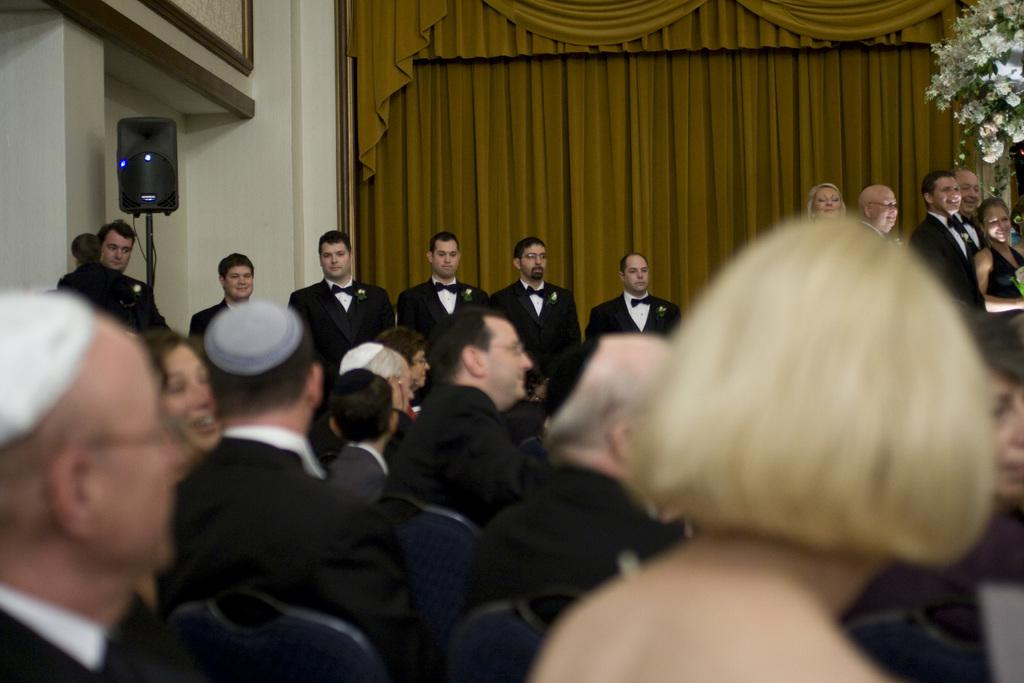What are the people in the image doing? The people in the image are sitting on chairs. Are there any other people visible in the image? Yes, there are people standing in the background of the image. What can be seen hanging in the image? There is a curtain in the image. What device is present in the image for amplifying sound? There is a speaker in the image. What type of decorative element is visible in the top right corner of the image? There are flowers visible in the top right corner of the image. How do the people in the image maintain their balance on the hill? There is no hill present in the image; it features people sitting on chairs and standing in the background. What is the temper of the speaker in the image? There is no indication of the speaker's temper in the image, as it only shows a speaker device and not the person using it. 